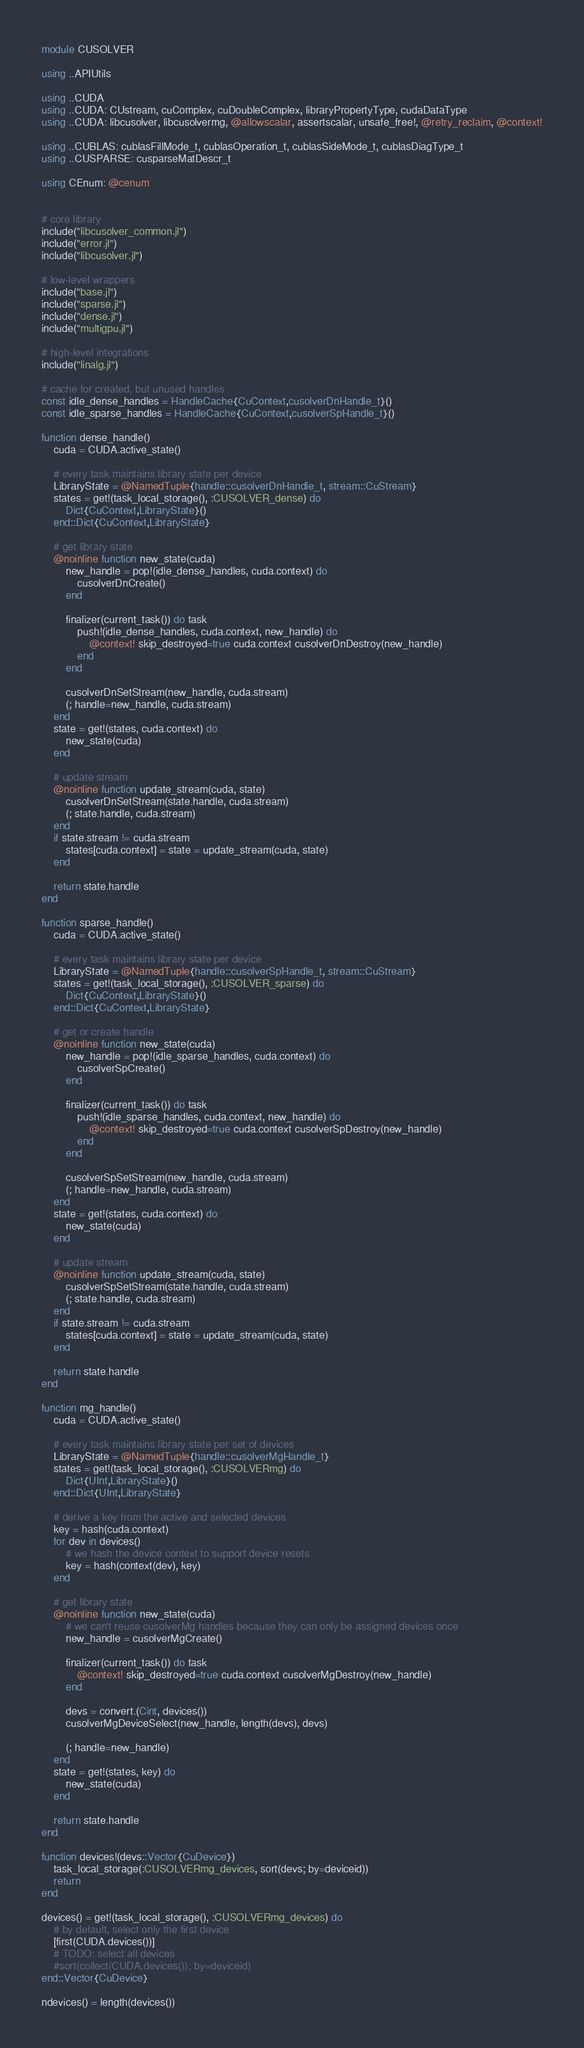<code> <loc_0><loc_0><loc_500><loc_500><_Julia_>module CUSOLVER

using ..APIUtils

using ..CUDA
using ..CUDA: CUstream, cuComplex, cuDoubleComplex, libraryPropertyType, cudaDataType
using ..CUDA: libcusolver, libcusolvermg, @allowscalar, assertscalar, unsafe_free!, @retry_reclaim, @context!

using ..CUBLAS: cublasFillMode_t, cublasOperation_t, cublasSideMode_t, cublasDiagType_t
using ..CUSPARSE: cusparseMatDescr_t

using CEnum: @cenum


# core library
include("libcusolver_common.jl")
include("error.jl")
include("libcusolver.jl")

# low-level wrappers
include("base.jl")
include("sparse.jl")
include("dense.jl")
include("multigpu.jl")

# high-level integrations
include("linalg.jl")

# cache for created, but unused handles
const idle_dense_handles = HandleCache{CuContext,cusolverDnHandle_t}()
const idle_sparse_handles = HandleCache{CuContext,cusolverSpHandle_t}()

function dense_handle()
    cuda = CUDA.active_state()

    # every task maintains library state per device
    LibraryState = @NamedTuple{handle::cusolverDnHandle_t, stream::CuStream}
    states = get!(task_local_storage(), :CUSOLVER_dense) do
        Dict{CuContext,LibraryState}()
    end::Dict{CuContext,LibraryState}

    # get library state
    @noinline function new_state(cuda)
        new_handle = pop!(idle_dense_handles, cuda.context) do
            cusolverDnCreate()
        end

        finalizer(current_task()) do task
            push!(idle_dense_handles, cuda.context, new_handle) do
                @context! skip_destroyed=true cuda.context cusolverDnDestroy(new_handle)
            end
        end

        cusolverDnSetStream(new_handle, cuda.stream)
        (; handle=new_handle, cuda.stream)
    end
    state = get!(states, cuda.context) do
        new_state(cuda)
    end

    # update stream
    @noinline function update_stream(cuda, state)
        cusolverDnSetStream(state.handle, cuda.stream)
        (; state.handle, cuda.stream)
    end
    if state.stream != cuda.stream
        states[cuda.context] = state = update_stream(cuda, state)
    end

    return state.handle
end

function sparse_handle()
    cuda = CUDA.active_state()

    # every task maintains library state per device
    LibraryState = @NamedTuple{handle::cusolverSpHandle_t, stream::CuStream}
    states = get!(task_local_storage(), :CUSOLVER_sparse) do
        Dict{CuContext,LibraryState}()
    end::Dict{CuContext,LibraryState}

    # get or create handle
    @noinline function new_state(cuda)
        new_handle = pop!(idle_sparse_handles, cuda.context) do
            cusolverSpCreate()
        end

        finalizer(current_task()) do task
            push!(idle_sparse_handles, cuda.context, new_handle) do
                @context! skip_destroyed=true cuda.context cusolverSpDestroy(new_handle)
            end
        end

        cusolverSpSetStream(new_handle, cuda.stream)
        (; handle=new_handle, cuda.stream)
    end
    state = get!(states, cuda.context) do
        new_state(cuda)
    end

    # update stream
    @noinline function update_stream(cuda, state)
        cusolverSpSetStream(state.handle, cuda.stream)
        (; state.handle, cuda.stream)
    end
    if state.stream != cuda.stream
        states[cuda.context] = state = update_stream(cuda, state)
    end

    return state.handle
end

function mg_handle()
    cuda = CUDA.active_state()

    # every task maintains library state per set of devices
    LibraryState = @NamedTuple{handle::cusolverMgHandle_t}
    states = get!(task_local_storage(), :CUSOLVERmg) do
        Dict{UInt,LibraryState}()
    end::Dict{UInt,LibraryState}

    # derive a key from the active and selected devices
    key = hash(cuda.context)
    for dev in devices()
        # we hash the device context to support device resets
        key = hash(context(dev), key)
    end

    # get library state
    @noinline function new_state(cuda)
        # we can't reuse cusolverMg handles because they can only be assigned devices once
        new_handle = cusolverMgCreate()

        finalizer(current_task()) do task
            @context! skip_destroyed=true cuda.context cusolverMgDestroy(new_handle)
        end

        devs = convert.(Cint, devices())
        cusolverMgDeviceSelect(new_handle, length(devs), devs)

        (; handle=new_handle)
    end
    state = get!(states, key) do
        new_state(cuda)
    end

    return state.handle
end

function devices!(devs::Vector{CuDevice})
    task_local_storage(:CUSOLVERmg_devices, sort(devs; by=deviceid))
    return
end

devices() = get!(task_local_storage(), :CUSOLVERmg_devices) do
    # by default, select only the first device
    [first(CUDA.devices())]
    # TODO: select all devices
    #sort(collect(CUDA.devices()); by=deviceid)
end::Vector{CuDevice}

ndevices() = length(devices())
</code> 